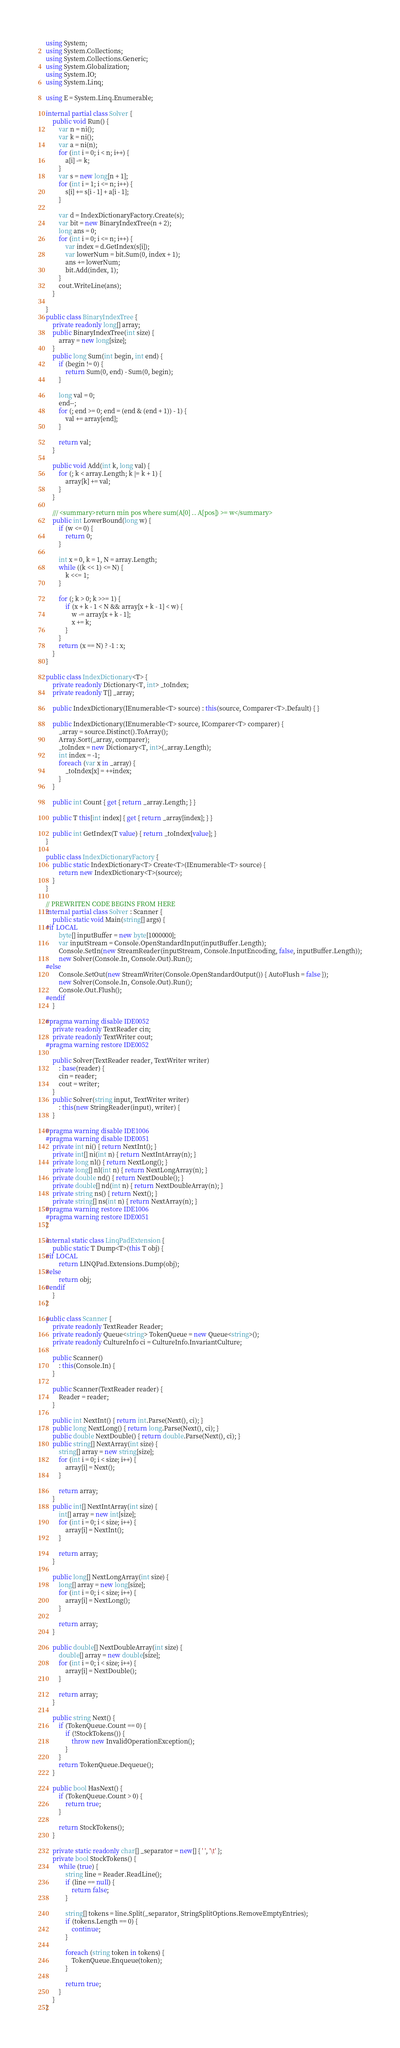Convert code to text. <code><loc_0><loc_0><loc_500><loc_500><_C#_>using System;
using System.Collections;
using System.Collections.Generic;
using System.Globalization;
using System.IO;
using System.Linq;

using E = System.Linq.Enumerable;

internal partial class Solver {
    public void Run() {
        var n = ni();
        var k = ni();
        var a = ni(n);
        for (int i = 0; i < n; i++) {
            a[i] -= k;
        }
        var s = new long[n + 1];
        for (int i = 1; i <= n; i++) {
            s[i] += s[i - 1] + a[i - 1];
        }

        var d = IndexDictionaryFactory.Create(s);
        var bit = new BinaryIndexTree(n + 2);
        long ans = 0;
        for (int i = 0; i <= n; i++) {
            var index = d.GetIndex(s[i]);
            var lowerNum = bit.Sum(0, index + 1);
            ans += lowerNum;
            bit.Add(index, 1);
        }
        cout.WriteLine(ans);
    }

}
public class BinaryIndexTree {
    private readonly long[] array;
    public BinaryIndexTree(int size) {
        array = new long[size];
    }
    public long Sum(int begin, int end) {
        if (begin != 0) {
            return Sum(0, end) - Sum(0, begin);
        }

        long val = 0;
        end--;
        for (; end >= 0; end = (end & (end + 1)) - 1) {
            val += array[end];
        }

        return val;
    }

    public void Add(int k, long val) {
        for (; k < array.Length; k |= k + 1) {
            array[k] += val;
        }
    }

    /// <summary>return min pos where sum(A[0] .. A[pos]) >= w</summary>
    public int LowerBound(long w) {
        if (w <= 0) {
            return 0;
        }

        int x = 0, k = 1, N = array.Length;
        while ((k << 1) <= N) {
            k <<= 1;
        }

        for (; k > 0; k >>= 1) {
            if (x + k - 1 < N && array[x + k - 1] < w) {
                w -= array[x + k - 1];
                x += k;
            }
        }
        return (x == N) ? -1 : x;
    }
}

public class IndexDictionary<T> {
    private readonly Dictionary<T, int> _toIndex;
    private readonly T[] _array;

    public IndexDictionary(IEnumerable<T> source) : this(source, Comparer<T>.Default) { }

    public IndexDictionary(IEnumerable<T> source, IComparer<T> comparer) {
        _array = source.Distinct().ToArray();
        Array.Sort(_array, comparer);
        _toIndex = new Dictionary<T, int>(_array.Length);
        int index = -1;
        foreach (var x in _array) {
            _toIndex[x] = ++index;
        }
    }

    public int Count { get { return _array.Length; } }

    public T this[int index] { get { return _array[index]; } }

    public int GetIndex(T value) { return _toIndex[value]; }
}

public class IndexDictionaryFactory {
    public static IndexDictionary<T> Create<T>(IEnumerable<T> source) {
        return new IndexDictionary<T>(source);
    }
}

// PREWRITEN CODE BEGINS FROM HERE
internal partial class Solver : Scanner {
    public static void Main(string[] args) {
#if LOCAL
        byte[] inputBuffer = new byte[1000000];
        var inputStream = Console.OpenStandardInput(inputBuffer.Length);
        Console.SetIn(new StreamReader(inputStream, Console.InputEncoding, false, inputBuffer.Length));
        new Solver(Console.In, Console.Out).Run();
#else
        Console.SetOut(new StreamWriter(Console.OpenStandardOutput()) { AutoFlush = false });
        new Solver(Console.In, Console.Out).Run();
        Console.Out.Flush();
#endif
    }

#pragma warning disable IDE0052
    private readonly TextReader cin;
    private readonly TextWriter cout;
#pragma warning restore IDE0052

    public Solver(TextReader reader, TextWriter writer)
        : base(reader) {
        cin = reader;
        cout = writer;
    }
    public Solver(string input, TextWriter writer)
        : this(new StringReader(input), writer) {
    }

#pragma warning disable IDE1006
#pragma warning disable IDE0051
    private int ni() { return NextInt(); }
    private int[] ni(int n) { return NextIntArray(n); }
    private long nl() { return NextLong(); }
    private long[] nl(int n) { return NextLongArray(n); }
    private double nd() { return NextDouble(); }
    private double[] nd(int n) { return NextDoubleArray(n); }
    private string ns() { return Next(); }
    private string[] ns(int n) { return NextArray(n); }
#pragma warning restore IDE1006
#pragma warning restore IDE0051
}

internal static class LinqPadExtension {
    public static T Dump<T>(this T obj) {
#if LOCAL
        return LINQPad.Extensions.Dump(obj);
#else
        return obj;
#endif
    }
}

public class Scanner {
    private readonly TextReader Reader;
    private readonly Queue<string> TokenQueue = new Queue<string>();
    private readonly CultureInfo ci = CultureInfo.InvariantCulture;

    public Scanner()
        : this(Console.In) {
    }

    public Scanner(TextReader reader) {
        Reader = reader;
    }

    public int NextInt() { return int.Parse(Next(), ci); }
    public long NextLong() { return long.Parse(Next(), ci); }
    public double NextDouble() { return double.Parse(Next(), ci); }
    public string[] NextArray(int size) {
        string[] array = new string[size];
        for (int i = 0; i < size; i++) {
            array[i] = Next();
        }

        return array;
    }
    public int[] NextIntArray(int size) {
        int[] array = new int[size];
        for (int i = 0; i < size; i++) {
            array[i] = NextInt();
        }

        return array;
    }

    public long[] NextLongArray(int size) {
        long[] array = new long[size];
        for (int i = 0; i < size; i++) {
            array[i] = NextLong();
        }

        return array;
    }

    public double[] NextDoubleArray(int size) {
        double[] array = new double[size];
        for (int i = 0; i < size; i++) {
            array[i] = NextDouble();
        }

        return array;
    }

    public string Next() {
        if (TokenQueue.Count == 0) {
            if (!StockTokens()) {
                throw new InvalidOperationException();
            }
        }
        return TokenQueue.Dequeue();
    }

    public bool HasNext() {
        if (TokenQueue.Count > 0) {
            return true;
        }

        return StockTokens();
    }

    private static readonly char[] _separator = new[] { ' ', '\t' };
    private bool StockTokens() {
        while (true) {
            string line = Reader.ReadLine();
            if (line == null) {
                return false;
            }

            string[] tokens = line.Split(_separator, StringSplitOptions.RemoveEmptyEntries);
            if (tokens.Length == 0) {
                continue;
            }

            foreach (string token in tokens) {
                TokenQueue.Enqueue(token);
            }

            return true;
        }
    }
}
</code> 